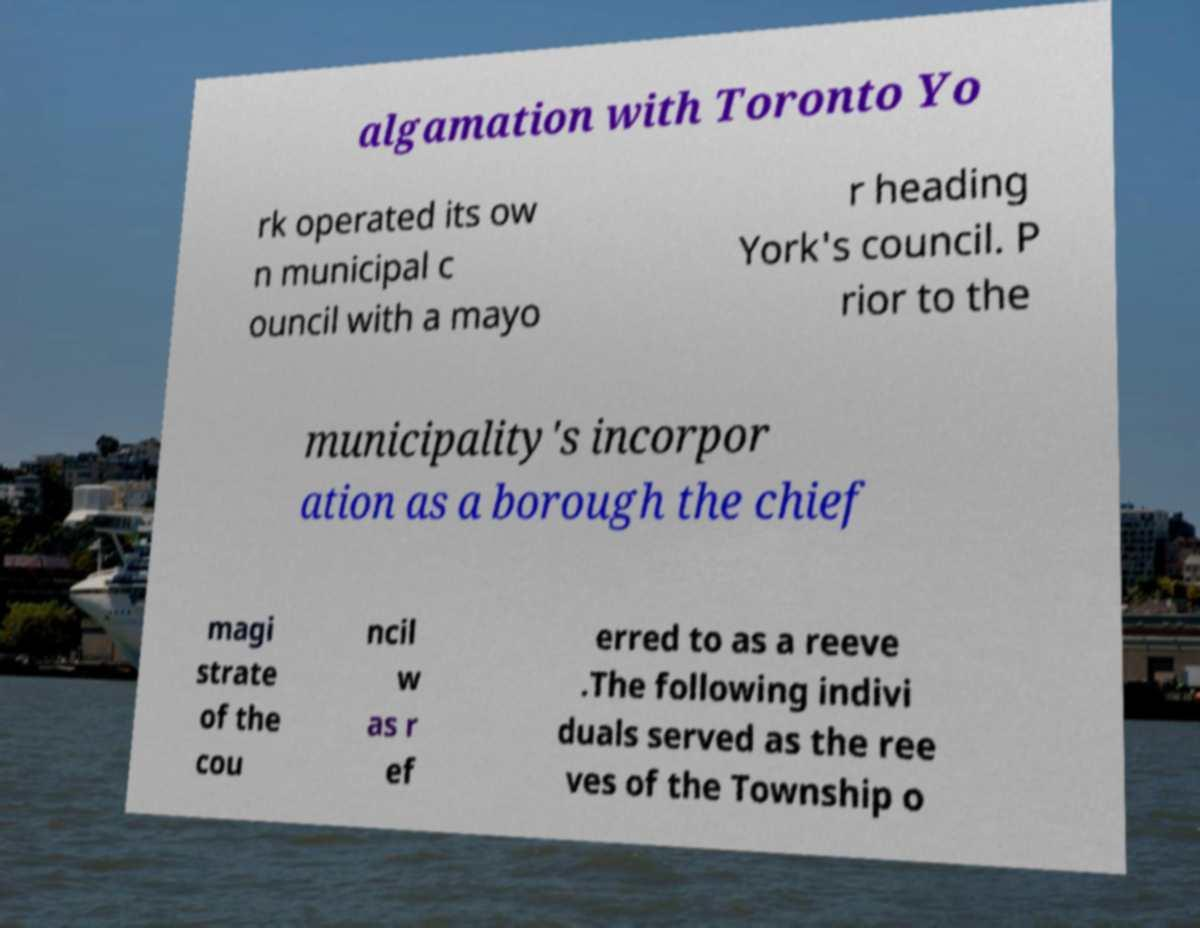Could you assist in decoding the text presented in this image and type it out clearly? algamation with Toronto Yo rk operated its ow n municipal c ouncil with a mayo r heading York's council. P rior to the municipality's incorpor ation as a borough the chief magi strate of the cou ncil w as r ef erred to as a reeve .The following indivi duals served as the ree ves of the Township o 